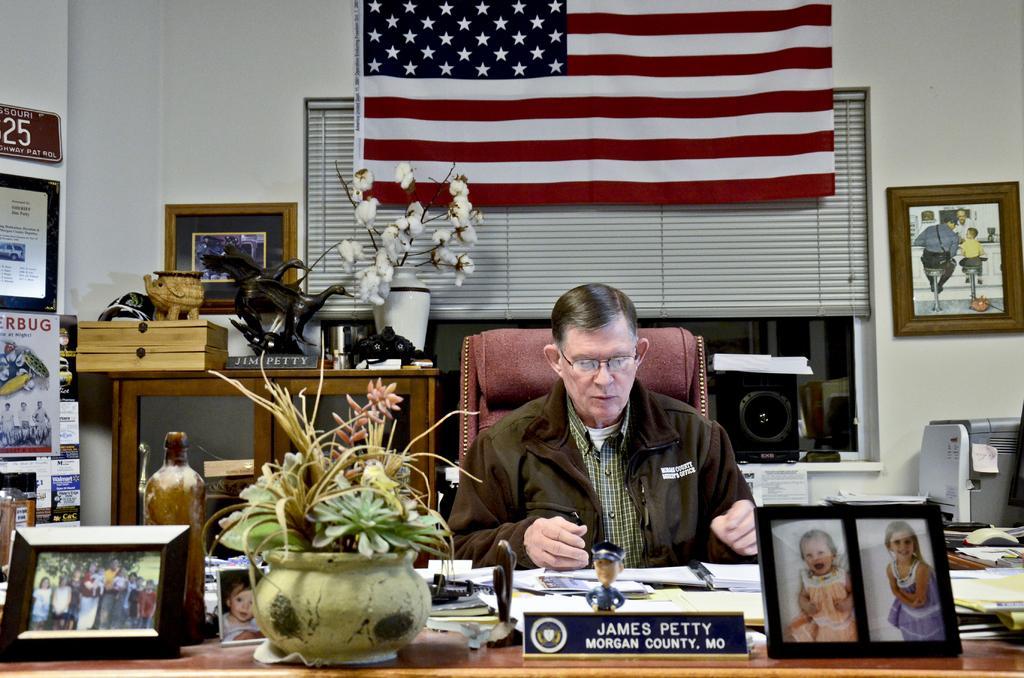How would you summarize this image in a sentence or two? This image is clicked in a room. It has a table in the bottom. That table has a photo frames, name board, flower pot, papers, books, files and a bottle. There is a flag on the top. Behind that flag there is a window blind and Windows and near that Windows there is a speaker. There is a photo frame on the right side and left side too. There are magazines and papers on the left side. There is a cupboard in this image. 